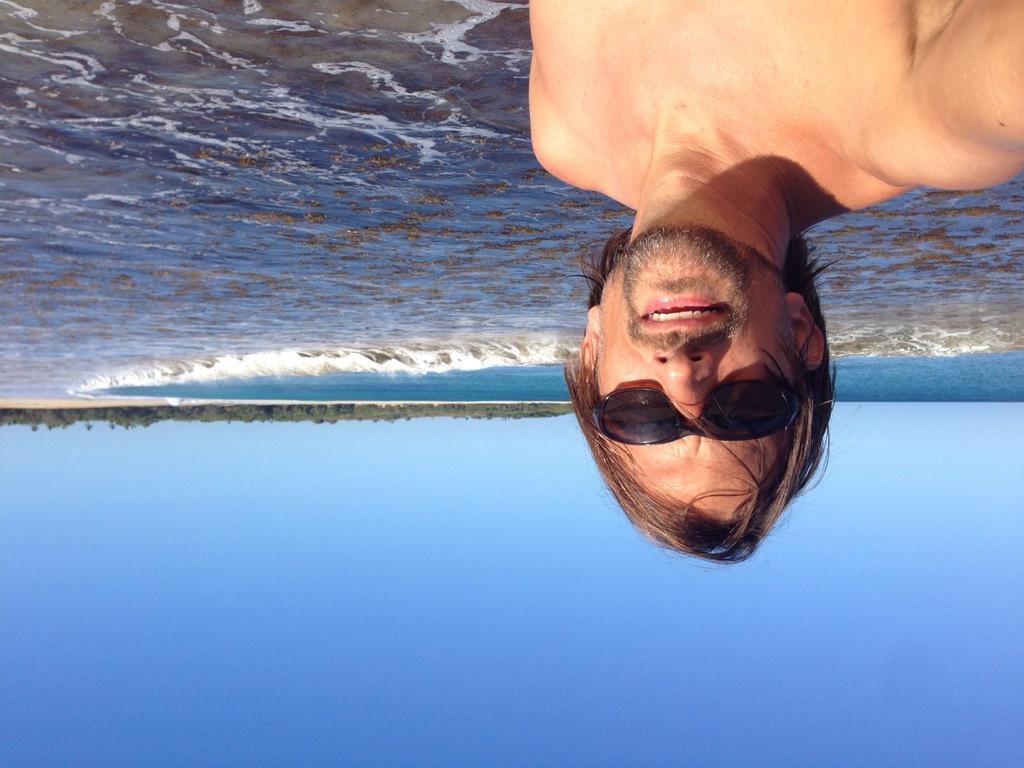How would you summarize this image in a sentence or two? In this image I can see a person wearing black color glasses. Back Side I can see a water and trees. The sky is in blue and white color. 